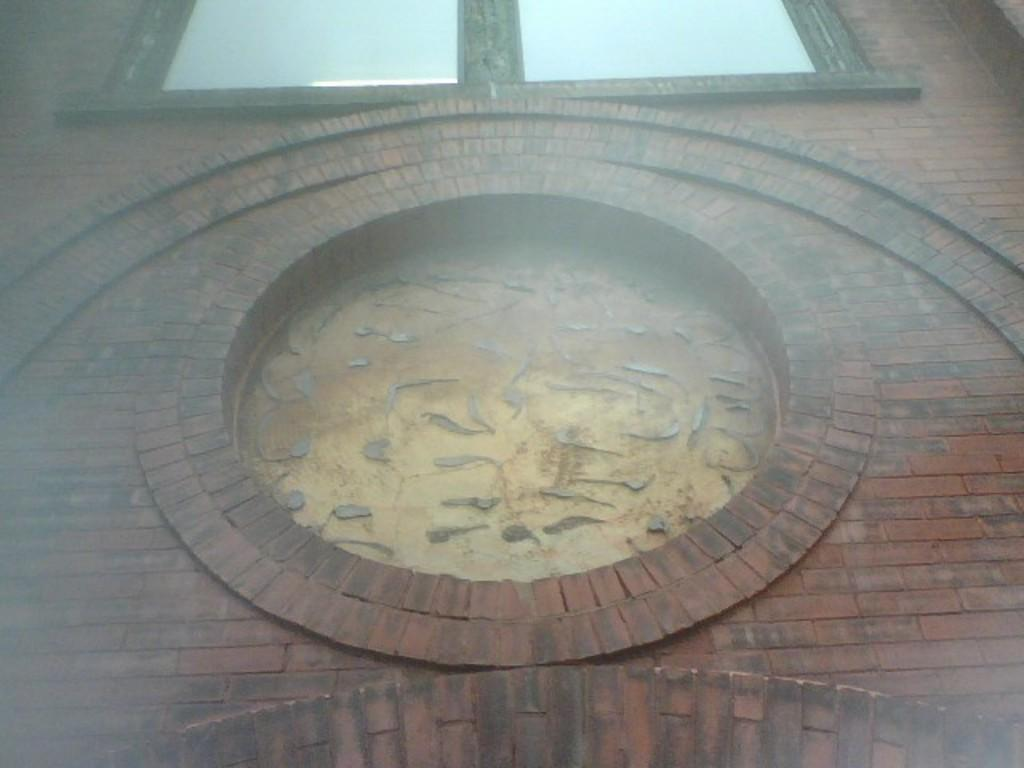What can be seen in the image? There is a wall in the image. What is unique about the wall? The wall has a hole in the middle. Is there anything else related to the wall in the image? Yes, there is a window above the hole in the wall. What color is the cherry that is hanging from the skirt in the image? There is no cherry or skirt present in the image; it only features a wall with a hole and a window above it. 